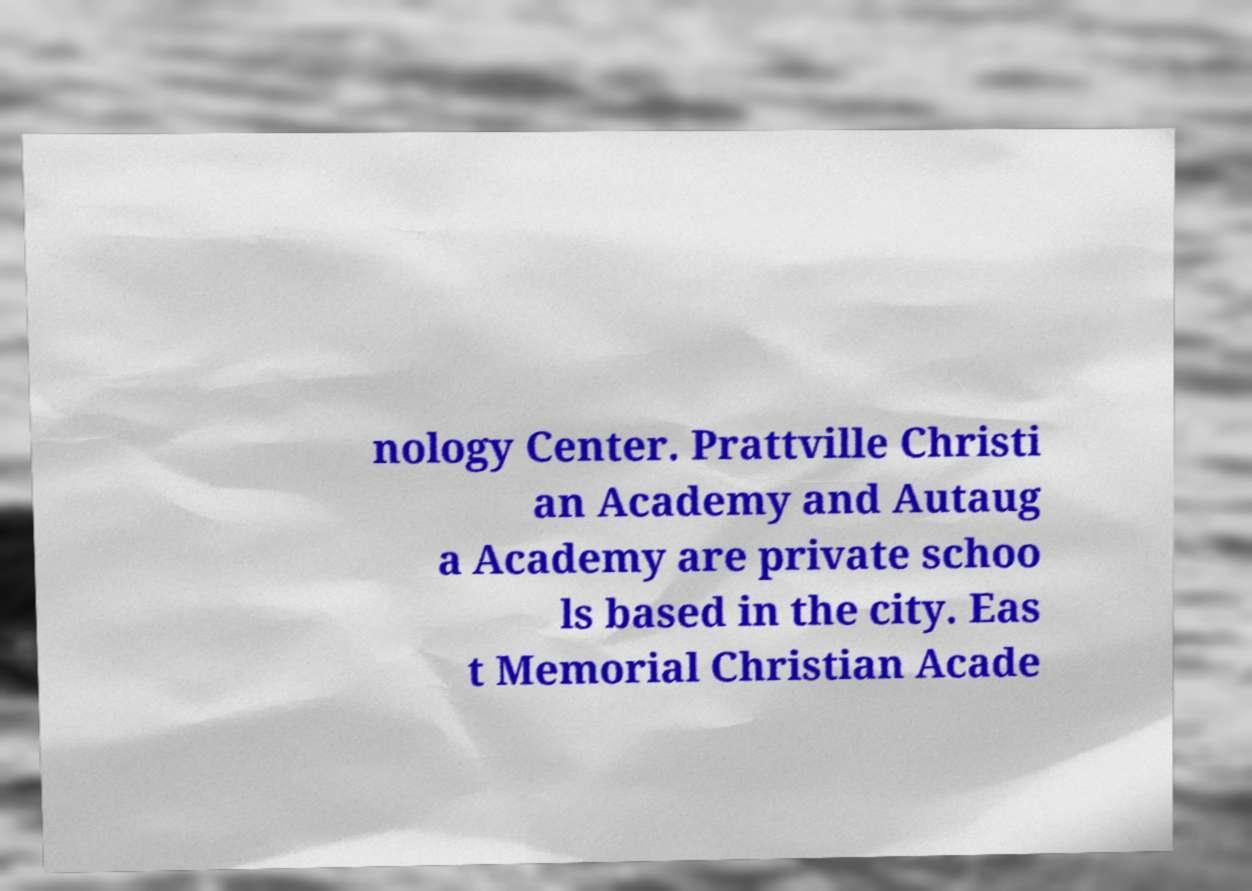For documentation purposes, I need the text within this image transcribed. Could you provide that? nology Center. Prattville Christi an Academy and Autaug a Academy are private schoo ls based in the city. Eas t Memorial Christian Acade 